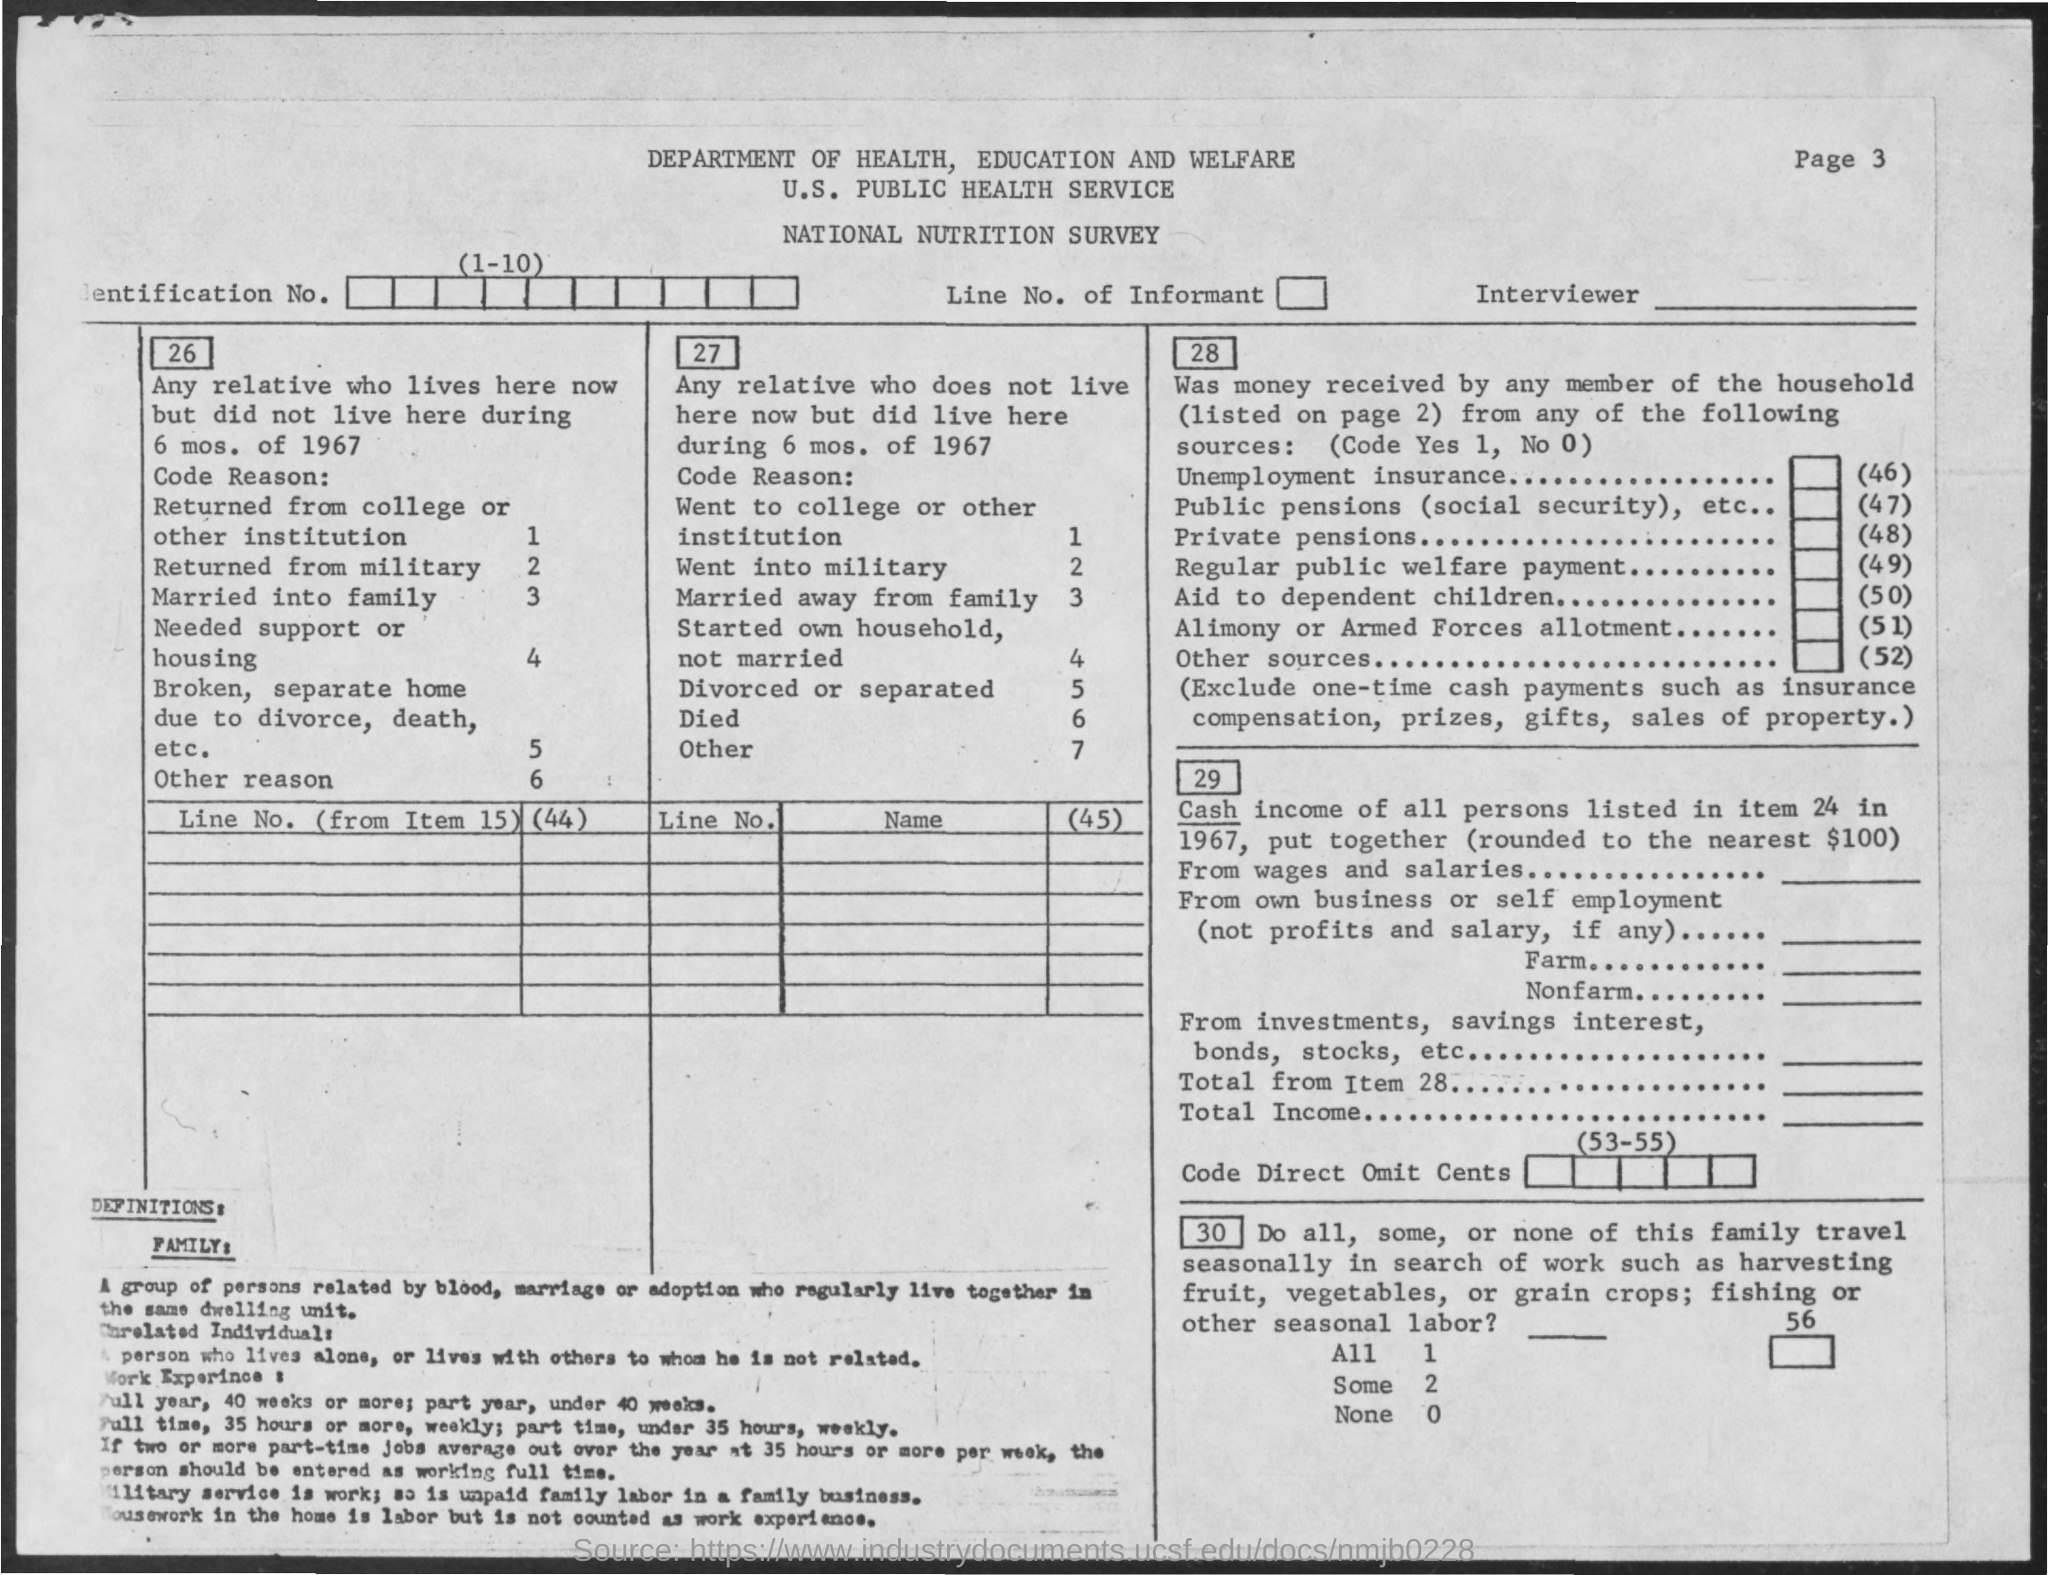What is the third title in the document?
Make the answer very short. National Nutrition Survey. Which department is mentioned in the title?
Your answer should be compact. Department of health, education and welfare. 